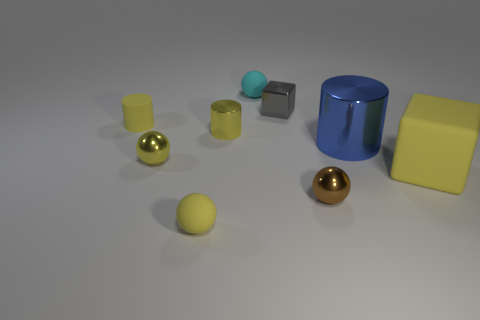Are there fewer yellow spheres than tiny green shiny blocks?
Your response must be concise. No. What shape is the small brown object?
Offer a terse response. Sphere. Does the matte ball in front of the brown object have the same color as the small block?
Your answer should be compact. No. The tiny rubber object that is both behind the blue cylinder and in front of the tiny gray cube has what shape?
Your answer should be compact. Cylinder. The object behind the small cube is what color?
Your answer should be compact. Cyan. Are there any other things that have the same color as the tiny block?
Give a very brief answer. No. Is the matte cube the same size as the brown object?
Your answer should be very brief. No. There is a thing that is to the right of the gray metallic thing and on the left side of the blue cylinder; what size is it?
Make the answer very short. Small. What number of other yellow blocks are made of the same material as the tiny block?
Provide a short and direct response. 0. What is the shape of the large object that is the same color as the small metal cylinder?
Provide a short and direct response. Cube. 